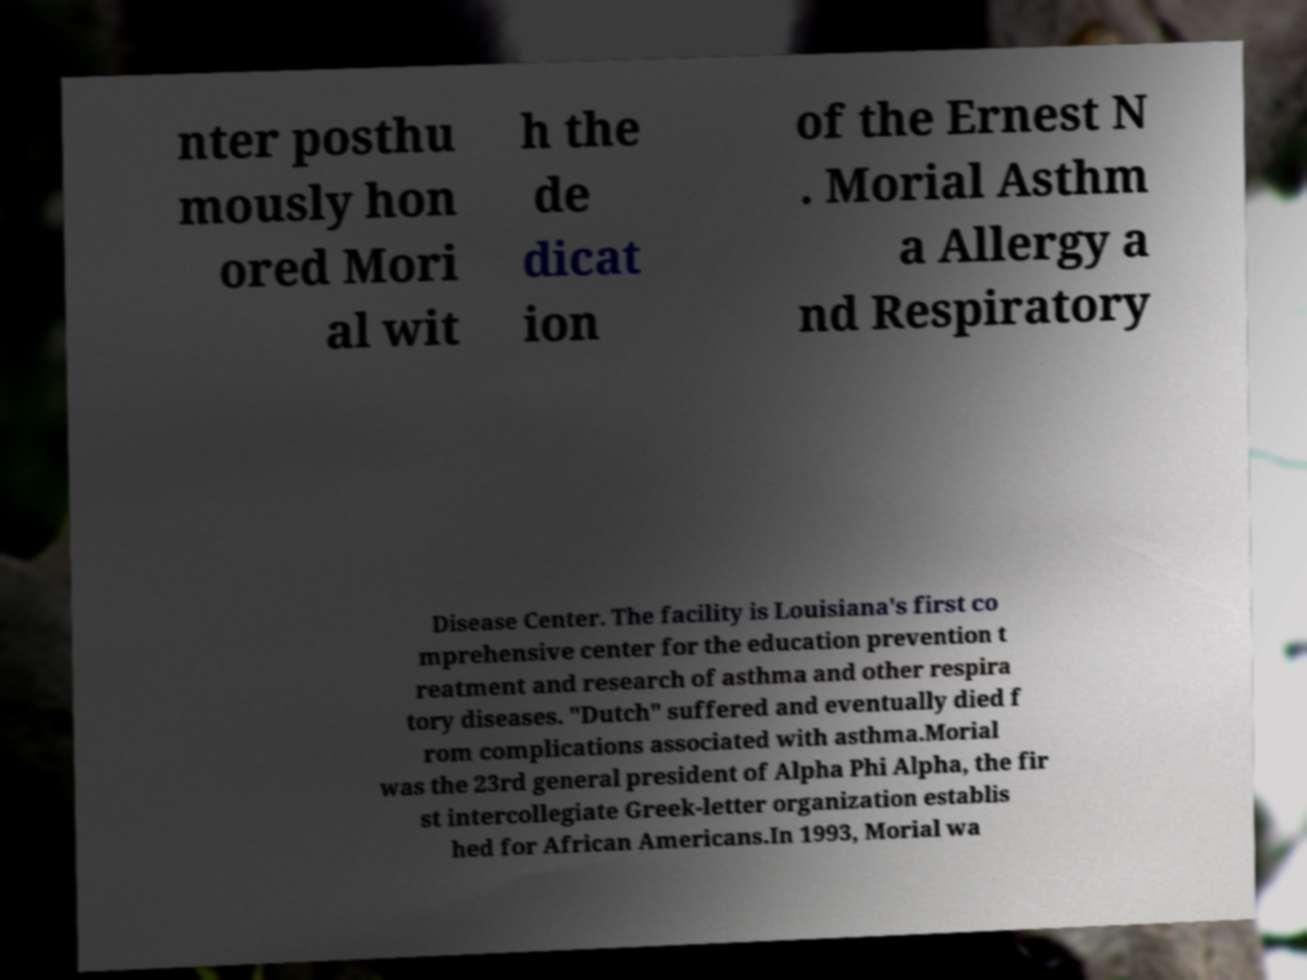For documentation purposes, I need the text within this image transcribed. Could you provide that? nter posthu mously hon ored Mori al wit h the de dicat ion of the Ernest N . Morial Asthm a Allergy a nd Respiratory Disease Center. The facility is Louisiana's first co mprehensive center for the education prevention t reatment and research of asthma and other respira tory diseases. "Dutch" suffered and eventually died f rom complications associated with asthma.Morial was the 23rd general president of Alpha Phi Alpha, the fir st intercollegiate Greek-letter organization establis hed for African Americans.In 1993, Morial wa 